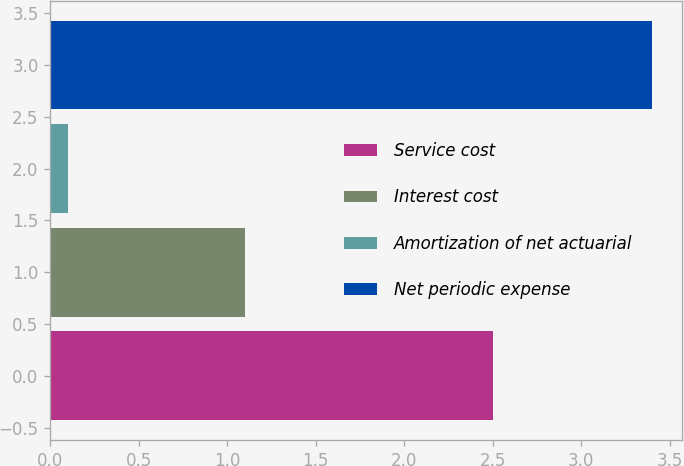<chart> <loc_0><loc_0><loc_500><loc_500><bar_chart><fcel>Service cost<fcel>Interest cost<fcel>Amortization of net actuarial<fcel>Net periodic expense<nl><fcel>2.5<fcel>1.1<fcel>0.1<fcel>3.4<nl></chart> 